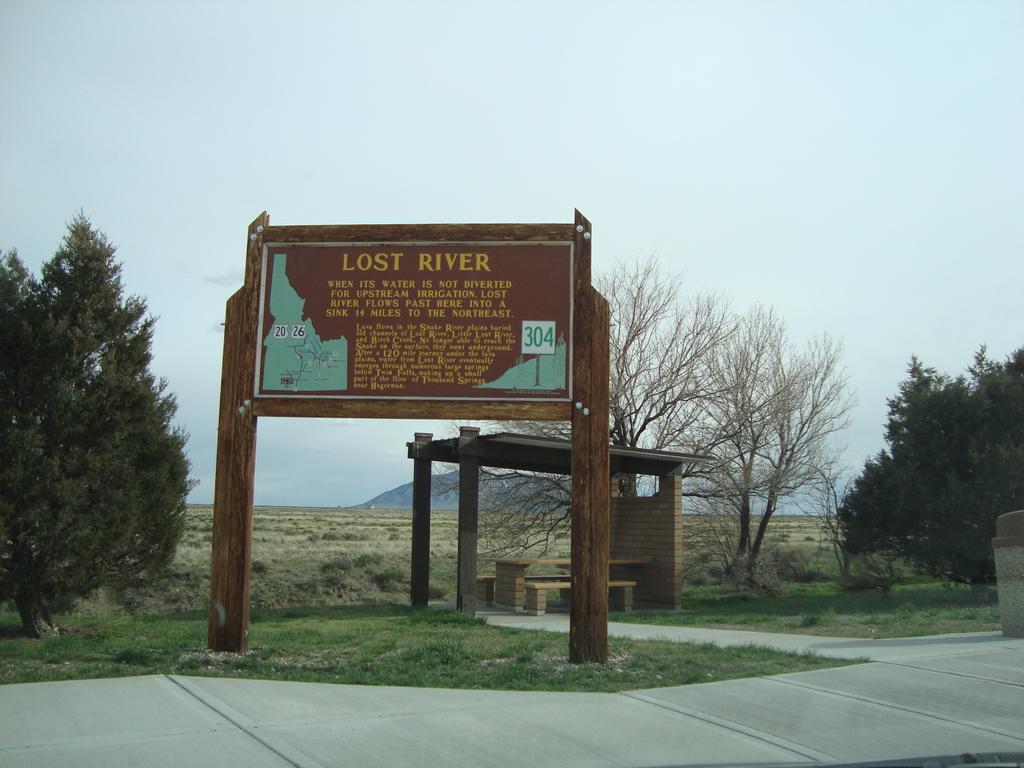Can you describe this image briefly? This picture describe about the brown color naming board on which "lost river" is written. Behind we can see tree and shed roof under which we can see a wooden bench and table. In the background we can see some dry trees and mountains. 